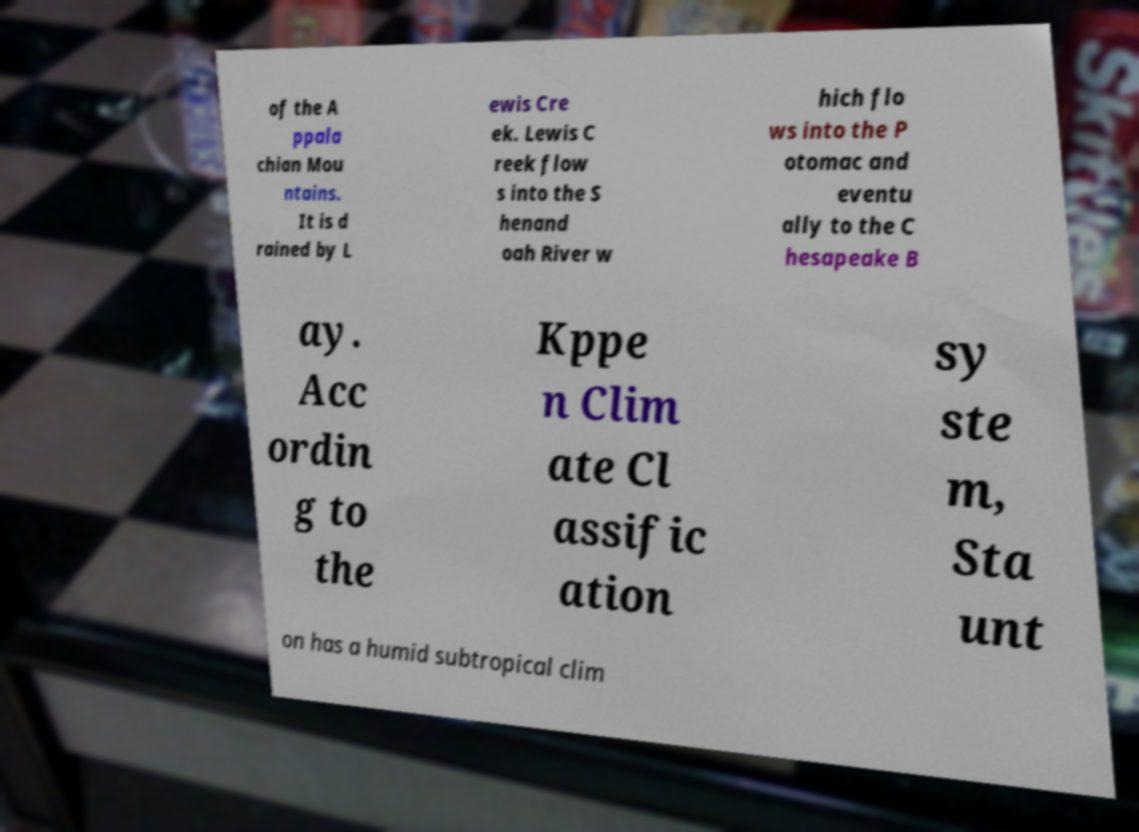What messages or text are displayed in this image? I need them in a readable, typed format. of the A ppala chian Mou ntains. It is d rained by L ewis Cre ek. Lewis C reek flow s into the S henand oah River w hich flo ws into the P otomac and eventu ally to the C hesapeake B ay. Acc ordin g to the Kppe n Clim ate Cl assific ation sy ste m, Sta unt on has a humid subtropical clim 